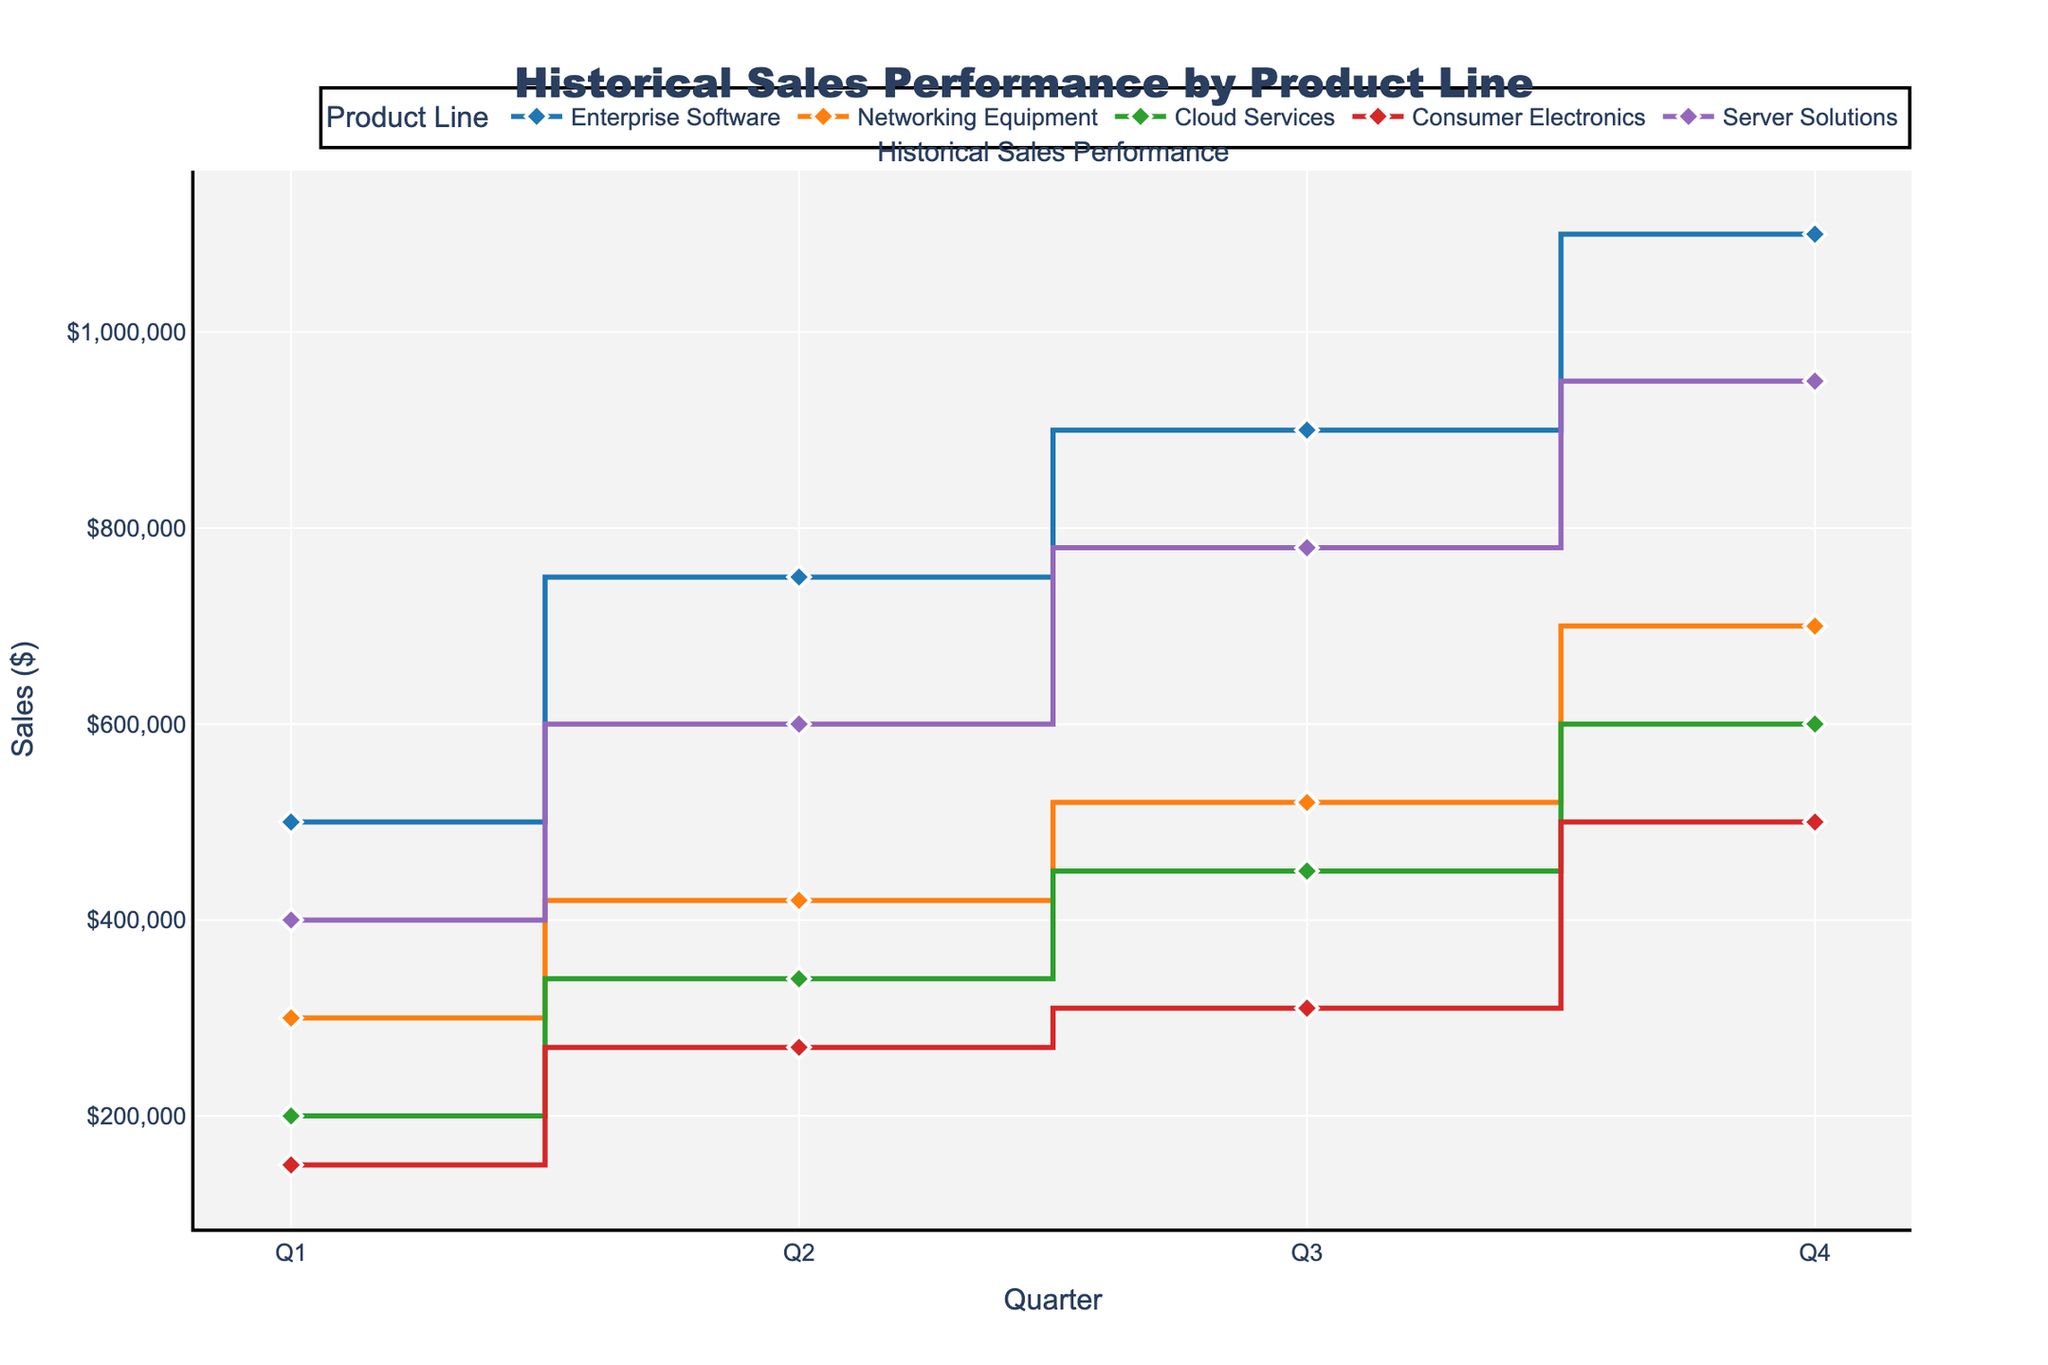Which Product Line had the highest sales in Q4? From the plot, we can see that the sales for each Product Line in Q4 are represented by the heights of the last steps. The highest step in Q4 corresponds to "Enterprise Software" with $1,100,000.
Answer: Enterprise Software What is the trend of sales for "Consumer Electronics" throughout the quarters? The plot shows four data points for "Consumer Electronics" connected by stairs. The sales start at $150,000 in Q1, increase to $270,000 in Q2, then to $310,000 in Q3, and finally reach $500,000 in Q4, showing a steady upward trend each quarter.
Answer: Steadily increasing How much more did "Enterprise Software" sell in Q4 compared to Q1? "Enterprise Software" had sales of $1,100,000 in Q4 and $500,000 in Q1. The difference is $1,100,000 - $500,000 = $600,000.
Answer: $600,000 Which Product Line showed the most consistent increase in sales every quarter? By observing the regularly ascending stair steps in the plot, "Enterprise Software" shows sales increasing consistently each quarter from Q1 to Q4 without any dips, indicating the most consistent increase.
Answer: Enterprise Software Out of the Product Lines, which had the lowest sales growth from Q3 to Q4? By comparing the difference between the Q3 and Q4 sales for each Product Line, we notice that "Consumer Electronics" had the smallest increase, from $310,000 in Q3 to $500,000 in Q4, with a growth of $190,000.
Answer: Consumer Electronics What is the total sales for "Server Solutions" for the entire fiscal year? The sales for "Server Solutions" across all quarters are: $400,000 (Q1), $600,000 (Q2), $780,000 (Q3), and $950,000 (Q4). Summing these: $400,000 + $600,000 + $780,000 + $950,000 gives a total of $2,730,000.
Answer: $2,730,000 How do "Cloud Services" Q4 sales compare to "Networking Equipment" Q4 sales? The Q4 sales for "Cloud Services" are $600,000 and for "Networking Equipment" are $700,000. This shows that "Cloud Services" sales are lower by $100,000 compared to "Networking Equipment."
Answer: Lower by $100,000 Which Product Line has shown the most significant leap in sales in any one quarter? By looking for the steepest stair step in the plot, "Enterprise Software" shows the most significant leap from Q2 to Q3, where sales rose from $750,000 to $900,000, an increase of $150,000.
Answer: Enterprise Software from Q2 to Q3 What is the average sales for "Networking Equipment" across all quarters? The sales for "Networking Equipment" each quarter are: $300,000 (Q1), $420,000 (Q2), $520,000 (Q3), and $700,000 (Q4). The sum is $300,000 + $420,000 + $520,000 + $700,000 = $1,940,000. Dividing by 4 gives an average of $485,000.
Answer: $485,000 